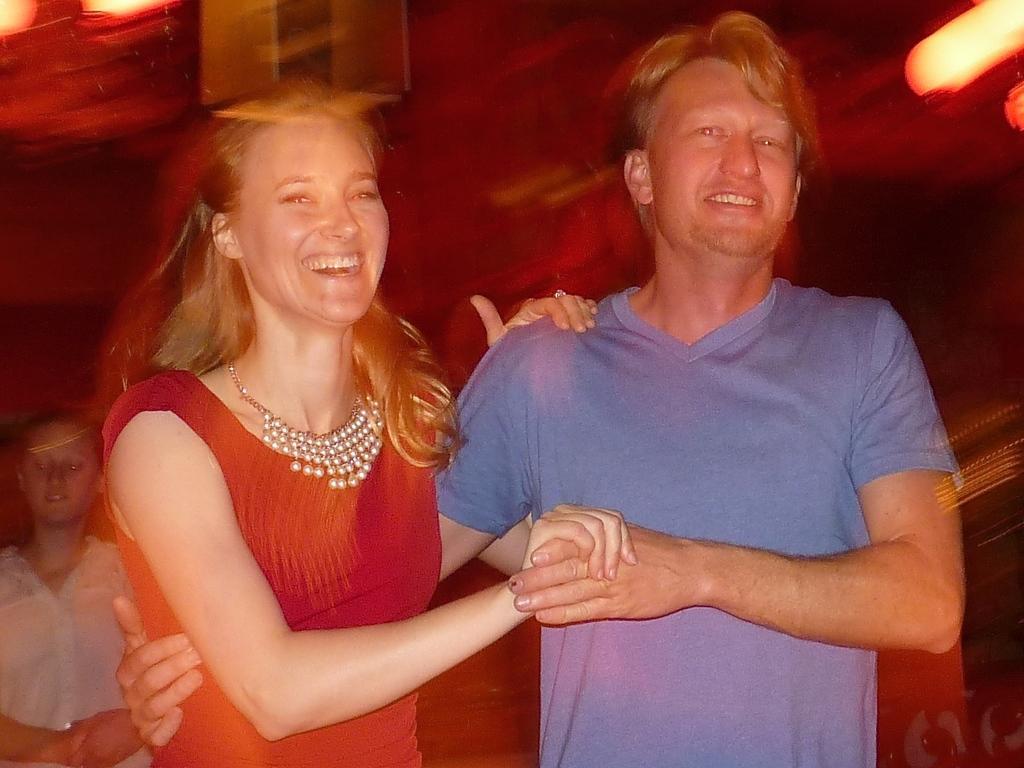In one or two sentences, can you explain what this image depicts? In this image, we can see a woman and man are holding hands with each other and smiling. Background we can see a blur we view. Here a person is there. Top of the image, we can see the lights. 